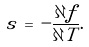Convert formula to latex. <formula><loc_0><loc_0><loc_500><loc_500>s \, = \, - \frac { \partial f } { \partial T } .</formula> 